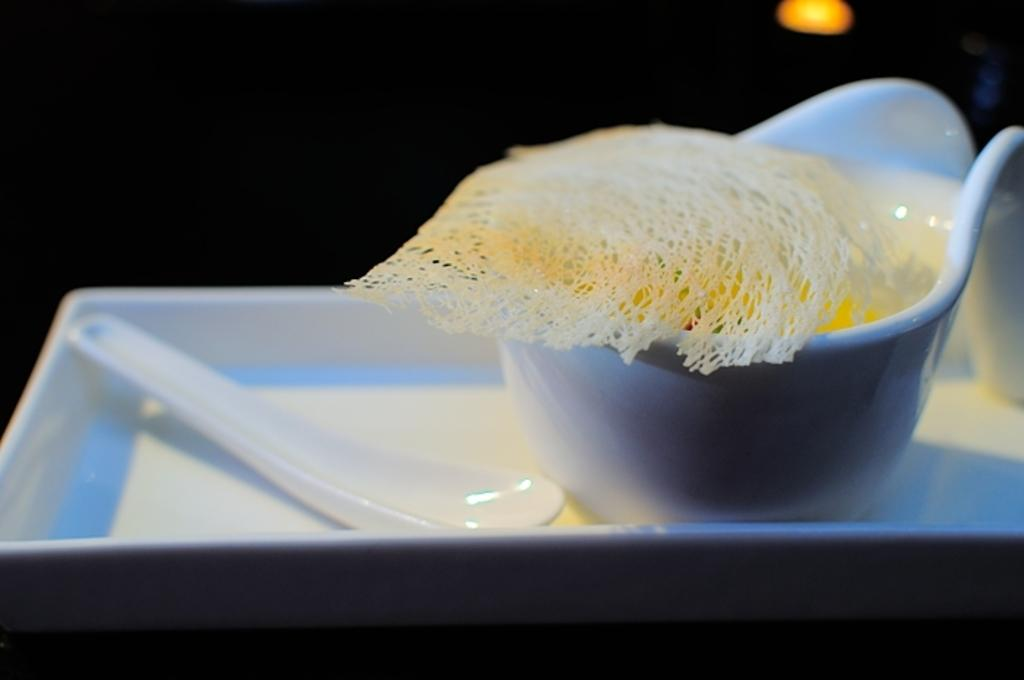What is on the plate in the image? There is a white color plate in the image, and a bowl is on the plate. What is inside the bowl? There is food in the bowl. What utensil is placed beside the bowl? There is a spoon beside the bowl. Can you describe the light in the image? There is a small light at the top of the image. How many men are visible in the market in the image? There is no market or men present in the image. What type of silver is used to make the plate in the image? The plate in the image is white, not silver. 